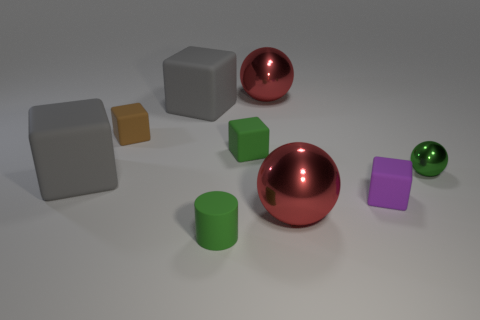How big is the green thing that is to the right of the metal sphere behind the small metallic sphere?
Make the answer very short. Small. There is a small shiny object; does it have the same color as the tiny rubber thing in front of the purple matte cube?
Give a very brief answer. Yes. Is there a purple object that has the same size as the brown matte object?
Make the answer very short. Yes. How big is the gray block that is behind the green block?
Provide a succinct answer. Large. There is a matte block that is behind the brown rubber thing; are there any small green rubber blocks that are behind it?
Provide a succinct answer. No. What number of other things are there of the same shape as the small brown matte thing?
Make the answer very short. 4. Do the small metallic object and the tiny brown object have the same shape?
Your response must be concise. No. What is the color of the metallic sphere that is both on the left side of the purple object and behind the tiny purple matte object?
Your answer should be compact. Red. There is a cube that is the same color as the tiny rubber cylinder; what size is it?
Give a very brief answer. Small. How many small objects are green matte blocks or green spheres?
Provide a short and direct response. 2. 